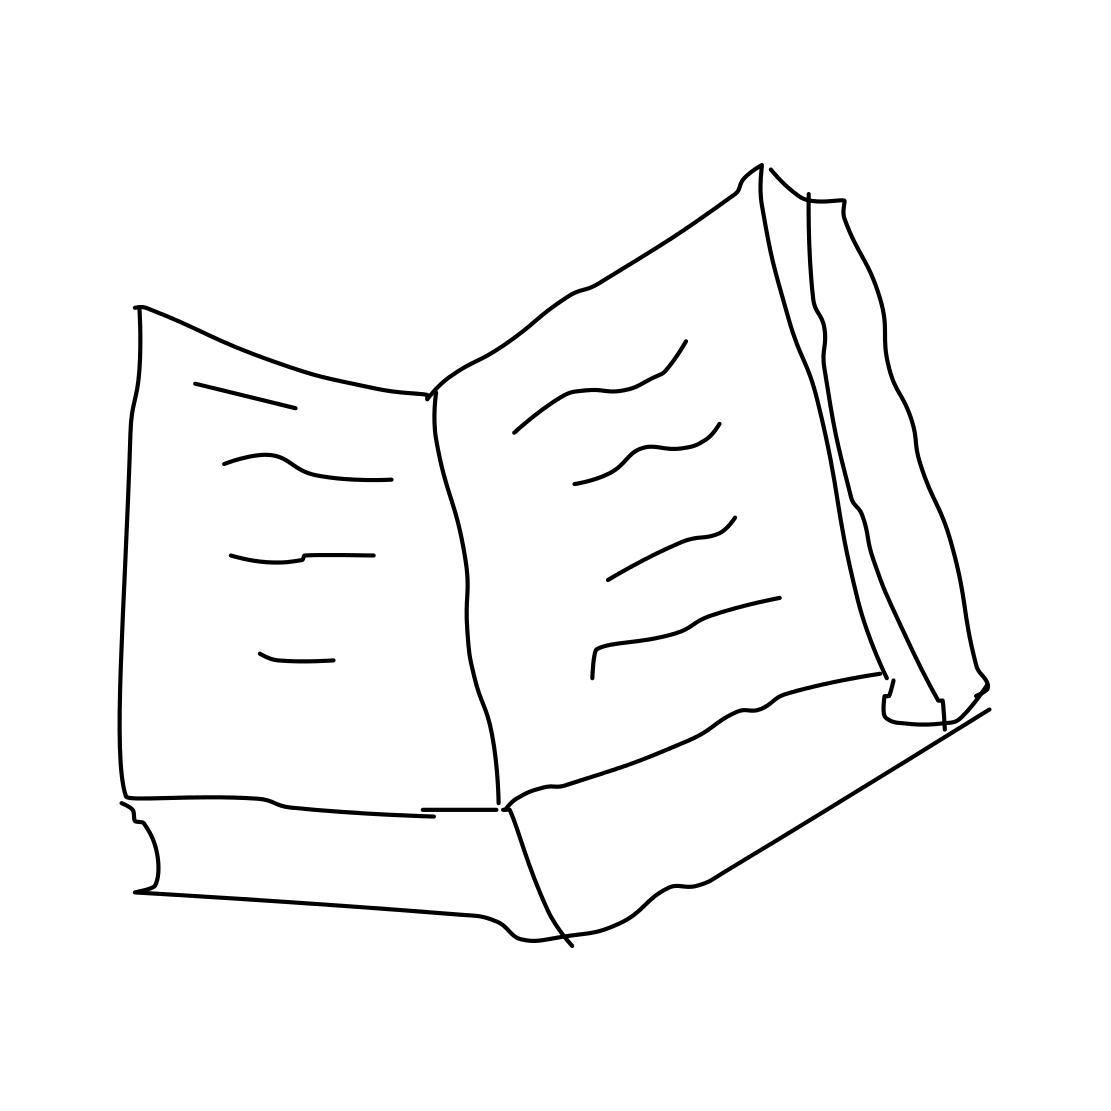Can you tell me what story might be in this book? Although the details of the text in the drawing are not discernible, one might imagine it's a classic adventure tale, filled with intriguing characters and far-off places. 